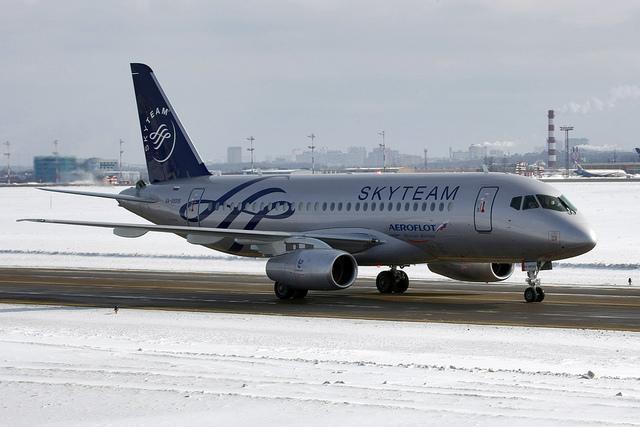How many bottles are on the table?
Give a very brief answer. 0. 